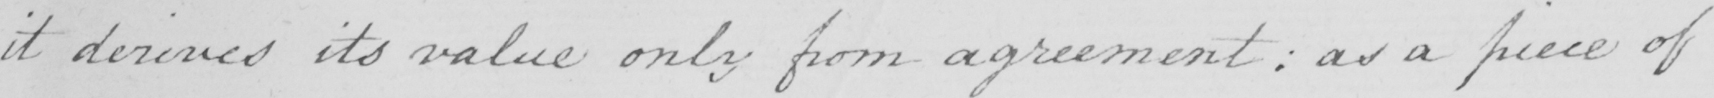What is written in this line of handwriting? it derives its value only from agreement  :  as a piece of 